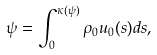Convert formula to latex. <formula><loc_0><loc_0><loc_500><loc_500>\psi = \int _ { 0 } ^ { \kappa ( \psi ) } \rho _ { 0 } u _ { 0 } ( s ) d s ,</formula> 